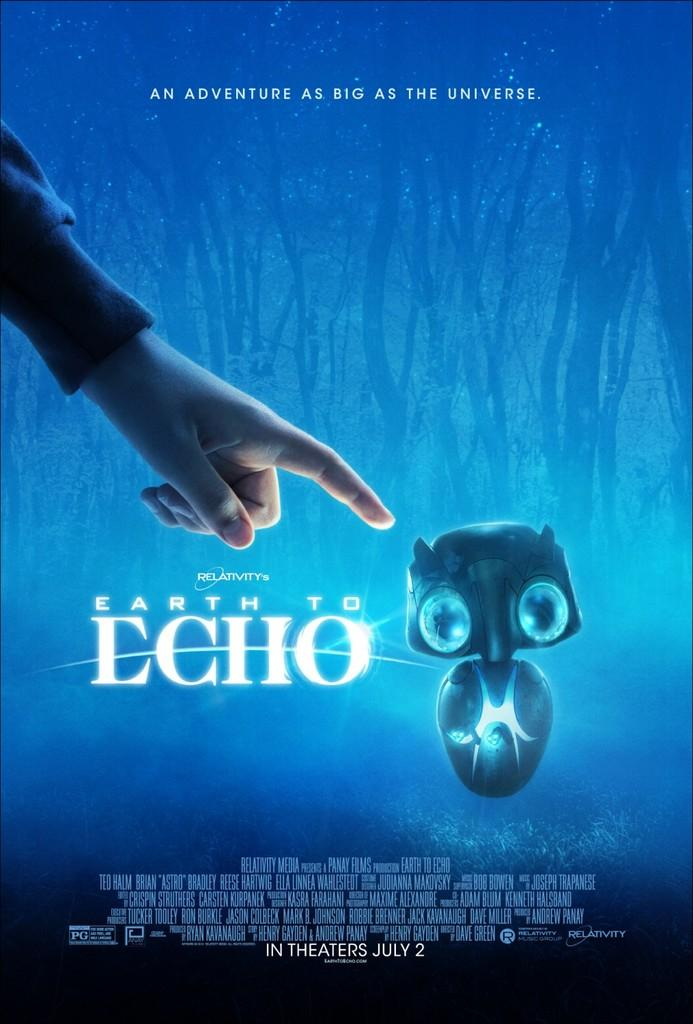<image>
Present a compact description of the photo's key features. A movie poster for Earth to Echo features a child pointing a finger at a robot. 